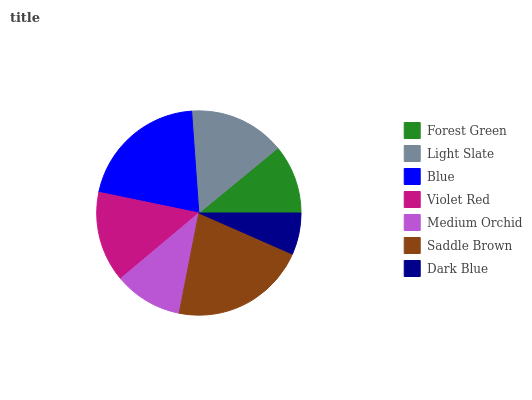Is Dark Blue the minimum?
Answer yes or no. Yes. Is Saddle Brown the maximum?
Answer yes or no. Yes. Is Light Slate the minimum?
Answer yes or no. No. Is Light Slate the maximum?
Answer yes or no. No. Is Light Slate greater than Forest Green?
Answer yes or no. Yes. Is Forest Green less than Light Slate?
Answer yes or no. Yes. Is Forest Green greater than Light Slate?
Answer yes or no. No. Is Light Slate less than Forest Green?
Answer yes or no. No. Is Violet Red the high median?
Answer yes or no. Yes. Is Violet Red the low median?
Answer yes or no. Yes. Is Dark Blue the high median?
Answer yes or no. No. Is Dark Blue the low median?
Answer yes or no. No. 